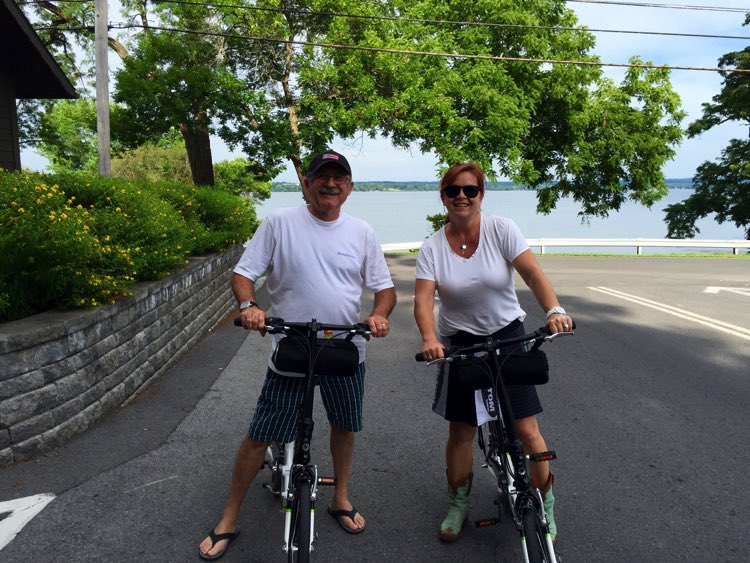Judging by the surroundings, what kind of area are the cyclists in? The area appears to be a tranquil, suburban or small-town setting by a large body of water, likely a lake. There's a well-maintained pavement bordered by a stone wall, lush trees, and vibrant yellow flowers. This suggests a well-kept, scenic route chosen for a peaceful biking experience. 